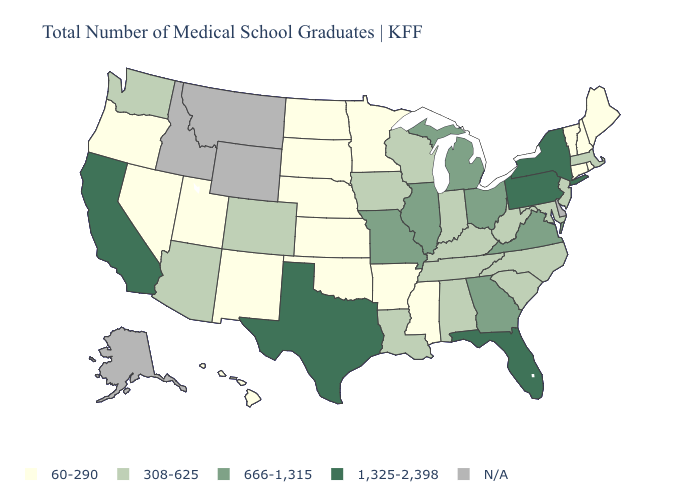Name the states that have a value in the range 666-1,315?
Give a very brief answer. Georgia, Illinois, Michigan, Missouri, Ohio, Virginia. Name the states that have a value in the range 1,325-2,398?
Be succinct. California, Florida, New York, Pennsylvania, Texas. What is the value of Pennsylvania?
Keep it brief. 1,325-2,398. What is the highest value in the USA?
Keep it brief. 1,325-2,398. What is the value of Maryland?
Quick response, please. 308-625. What is the value of Virginia?
Answer briefly. 666-1,315. What is the value of New Jersey?
Give a very brief answer. 308-625. What is the value of Montana?
Keep it brief. N/A. Which states have the lowest value in the West?
Give a very brief answer. Hawaii, Nevada, New Mexico, Oregon, Utah. Among the states that border Iowa , which have the lowest value?
Short answer required. Minnesota, Nebraska, South Dakota. Does the first symbol in the legend represent the smallest category?
Give a very brief answer. Yes. How many symbols are there in the legend?
Give a very brief answer. 5. How many symbols are there in the legend?
Write a very short answer. 5. Which states have the lowest value in the West?
Be succinct. Hawaii, Nevada, New Mexico, Oregon, Utah. Does the map have missing data?
Write a very short answer. Yes. 